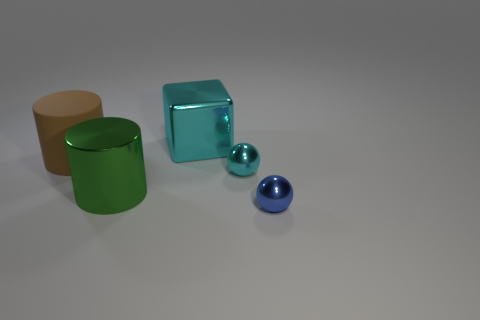Add 4 green cylinders. How many objects exist? 9 Subtract all cubes. How many objects are left? 4 Add 1 brown matte cylinders. How many brown matte cylinders exist? 2 Subtract 0 red balls. How many objects are left? 5 Subtract all cyan metal objects. Subtract all blue matte cylinders. How many objects are left? 3 Add 4 green objects. How many green objects are left? 5 